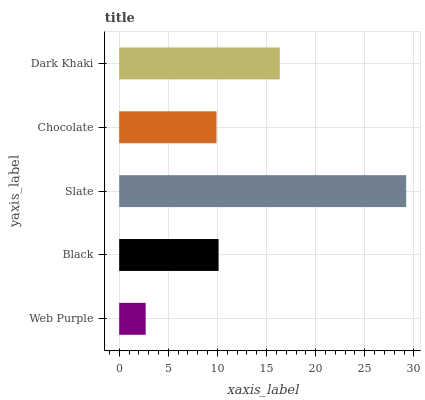Is Web Purple the minimum?
Answer yes or no. Yes. Is Slate the maximum?
Answer yes or no. Yes. Is Black the minimum?
Answer yes or no. No. Is Black the maximum?
Answer yes or no. No. Is Black greater than Web Purple?
Answer yes or no. Yes. Is Web Purple less than Black?
Answer yes or no. Yes. Is Web Purple greater than Black?
Answer yes or no. No. Is Black less than Web Purple?
Answer yes or no. No. Is Black the high median?
Answer yes or no. Yes. Is Black the low median?
Answer yes or no. Yes. Is Slate the high median?
Answer yes or no. No. Is Web Purple the low median?
Answer yes or no. No. 